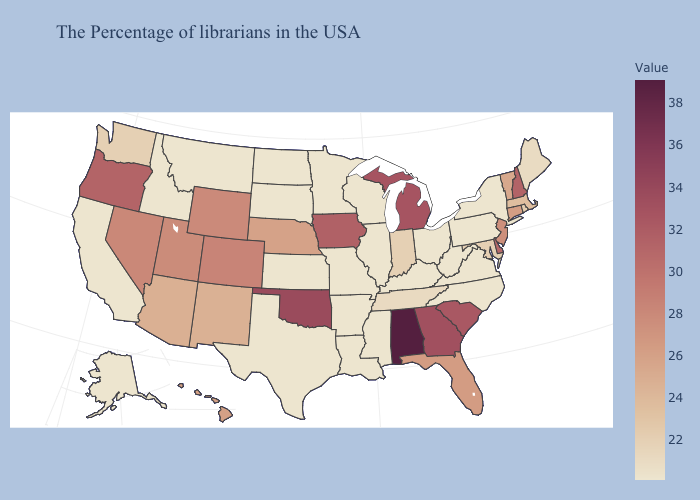Does Alabama have the highest value in the South?
Be succinct. Yes. Among the states that border Pennsylvania , which have the highest value?
Short answer required. Delaware. Does the map have missing data?
Write a very short answer. No. Which states have the lowest value in the South?
Write a very short answer. Virginia, North Carolina, West Virginia, Kentucky, Mississippi, Louisiana, Arkansas, Texas. Does Arkansas have the lowest value in the USA?
Answer briefly. Yes. 